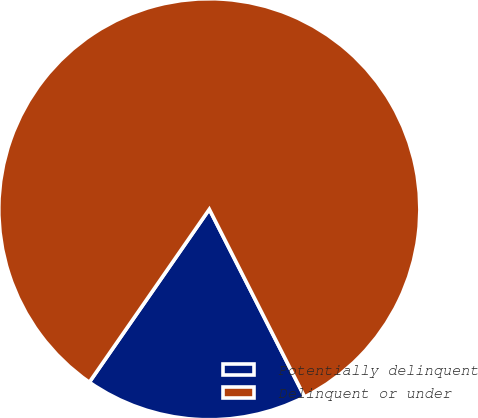Convert chart to OTSL. <chart><loc_0><loc_0><loc_500><loc_500><pie_chart><fcel>Potentially delinquent<fcel>Delinquent or under<nl><fcel>17.13%<fcel>82.87%<nl></chart> 